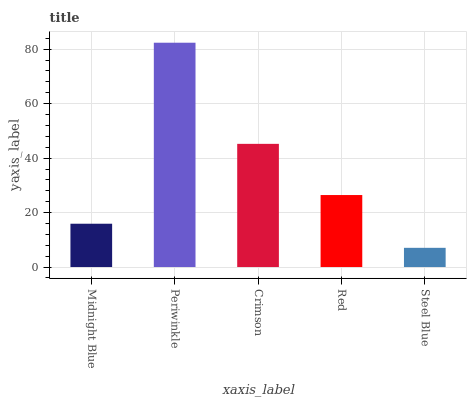Is Steel Blue the minimum?
Answer yes or no. Yes. Is Periwinkle the maximum?
Answer yes or no. Yes. Is Crimson the minimum?
Answer yes or no. No. Is Crimson the maximum?
Answer yes or no. No. Is Periwinkle greater than Crimson?
Answer yes or no. Yes. Is Crimson less than Periwinkle?
Answer yes or no. Yes. Is Crimson greater than Periwinkle?
Answer yes or no. No. Is Periwinkle less than Crimson?
Answer yes or no. No. Is Red the high median?
Answer yes or no. Yes. Is Red the low median?
Answer yes or no. Yes. Is Steel Blue the high median?
Answer yes or no. No. Is Crimson the low median?
Answer yes or no. No. 